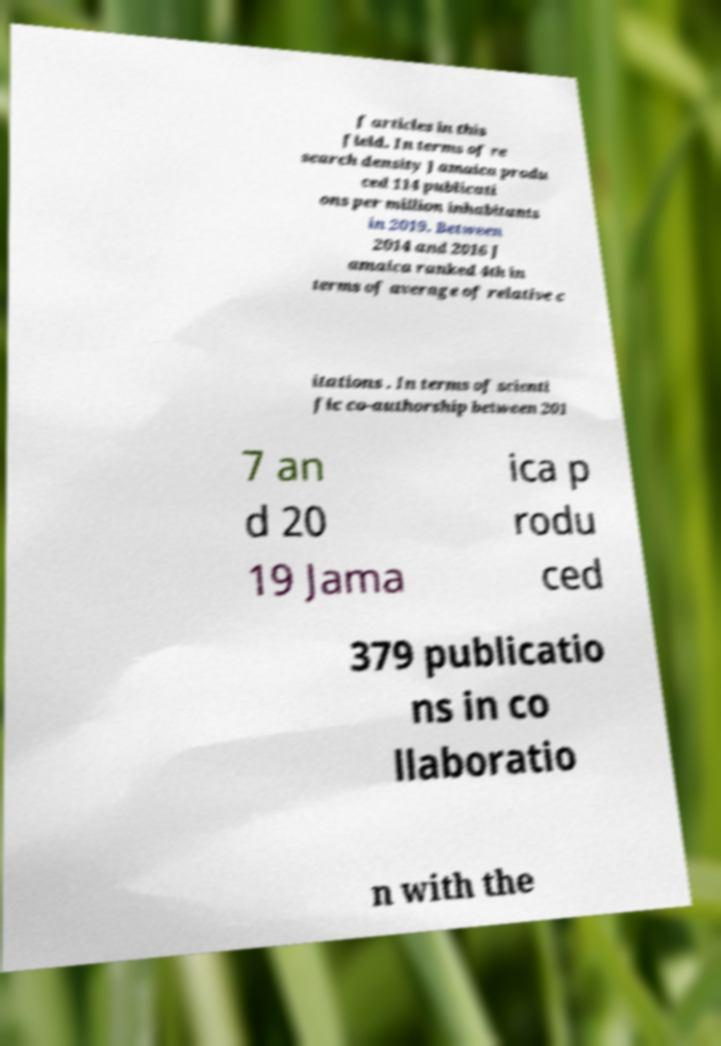Can you read and provide the text displayed in the image?This photo seems to have some interesting text. Can you extract and type it out for me? f articles in this field. In terms of re search density Jamaica produ ced 114 publicati ons per million inhabitants in 2019. Between 2014 and 2016 J amaica ranked 4th in terms of average of relative c itations . In terms of scienti fic co-authorship between 201 7 an d 20 19 Jama ica p rodu ced 379 publicatio ns in co llaboratio n with the 